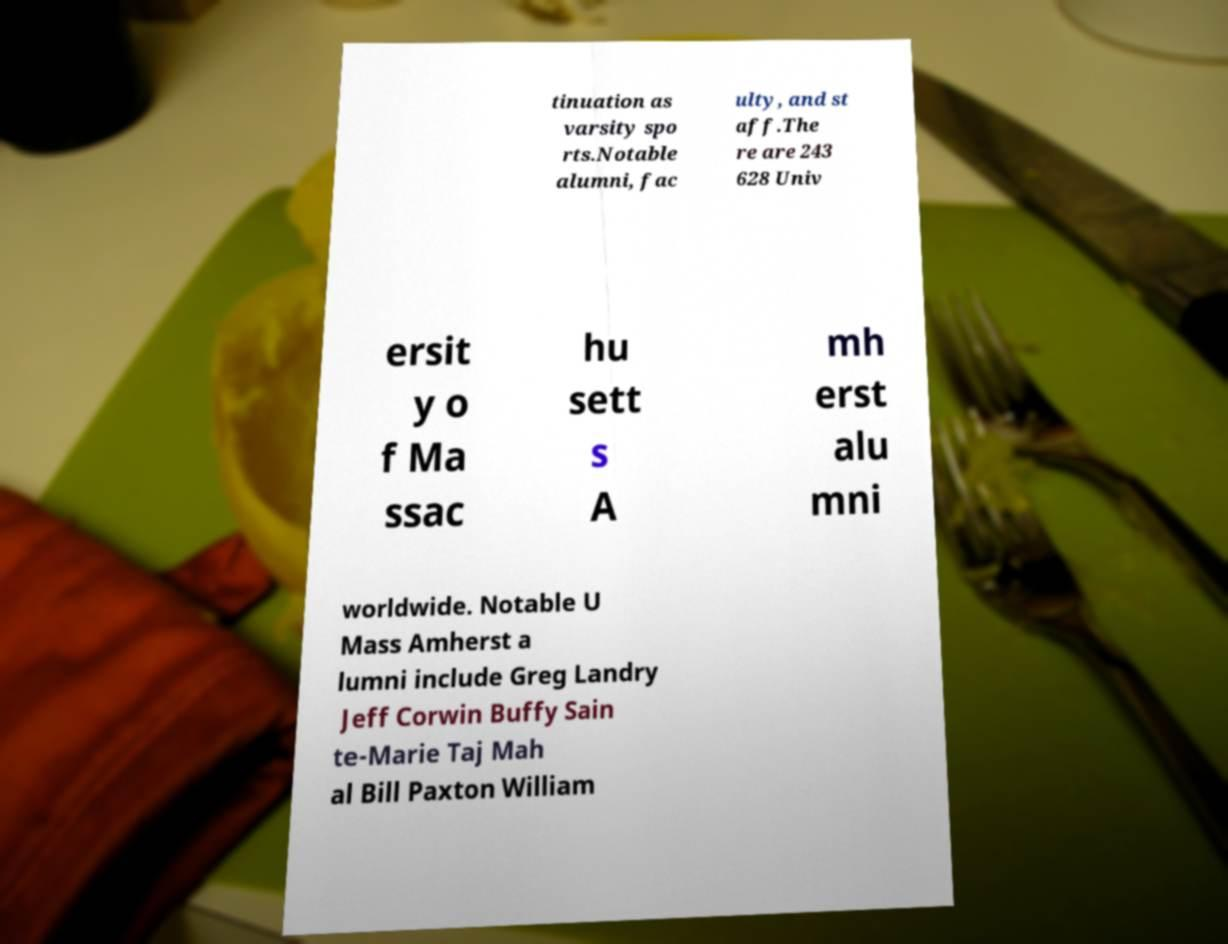What messages or text are displayed in this image? I need them in a readable, typed format. tinuation as varsity spo rts.Notable alumni, fac ulty, and st aff.The re are 243 628 Univ ersit y o f Ma ssac hu sett s A mh erst alu mni worldwide. Notable U Mass Amherst a lumni include Greg Landry Jeff Corwin Buffy Sain te-Marie Taj Mah al Bill Paxton William 